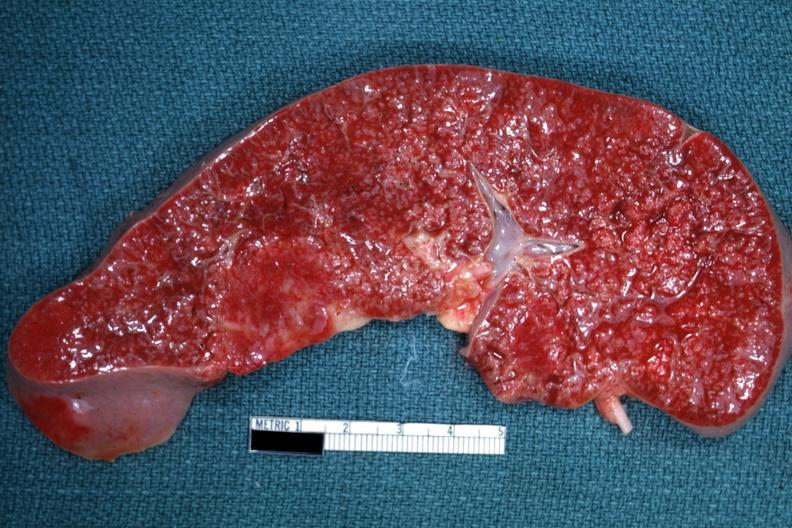what is present?
Answer the question using a single word or phrase. Spleen 